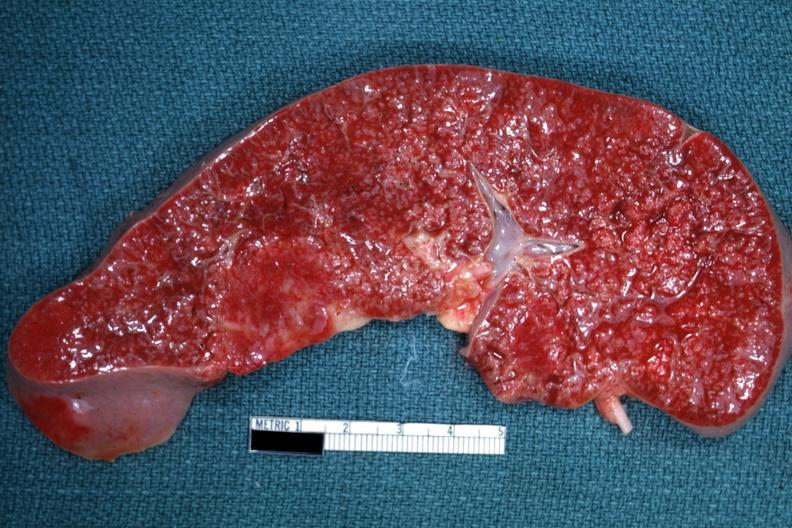what is present?
Answer the question using a single word or phrase. Spleen 